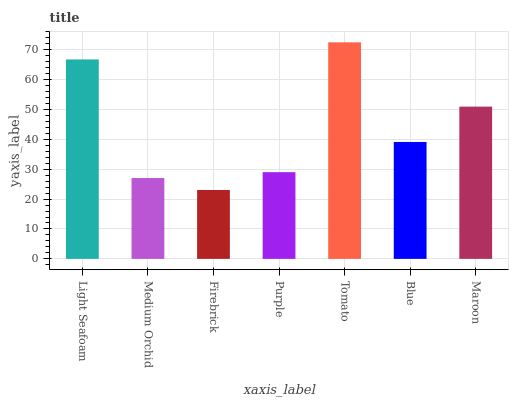Is Firebrick the minimum?
Answer yes or no. Yes. Is Tomato the maximum?
Answer yes or no. Yes. Is Medium Orchid the minimum?
Answer yes or no. No. Is Medium Orchid the maximum?
Answer yes or no. No. Is Light Seafoam greater than Medium Orchid?
Answer yes or no. Yes. Is Medium Orchid less than Light Seafoam?
Answer yes or no. Yes. Is Medium Orchid greater than Light Seafoam?
Answer yes or no. No. Is Light Seafoam less than Medium Orchid?
Answer yes or no. No. Is Blue the high median?
Answer yes or no. Yes. Is Blue the low median?
Answer yes or no. Yes. Is Light Seafoam the high median?
Answer yes or no. No. Is Medium Orchid the low median?
Answer yes or no. No. 